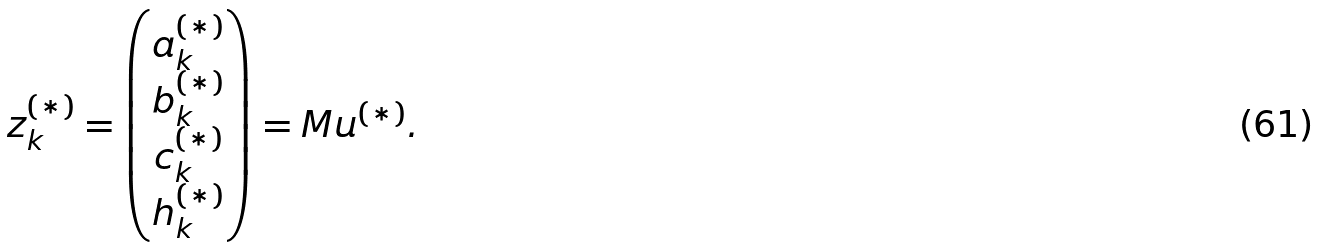Convert formula to latex. <formula><loc_0><loc_0><loc_500><loc_500>z _ { k } ^ { ( * ) } = \begin{pmatrix} a _ { k } ^ { ( * ) } \\ b _ { k } ^ { ( * ) } \\ c _ { k } ^ { ( * ) } \\ h _ { k } ^ { ( * ) } \\ \end{pmatrix} = M u ^ { ( * ) } .</formula> 